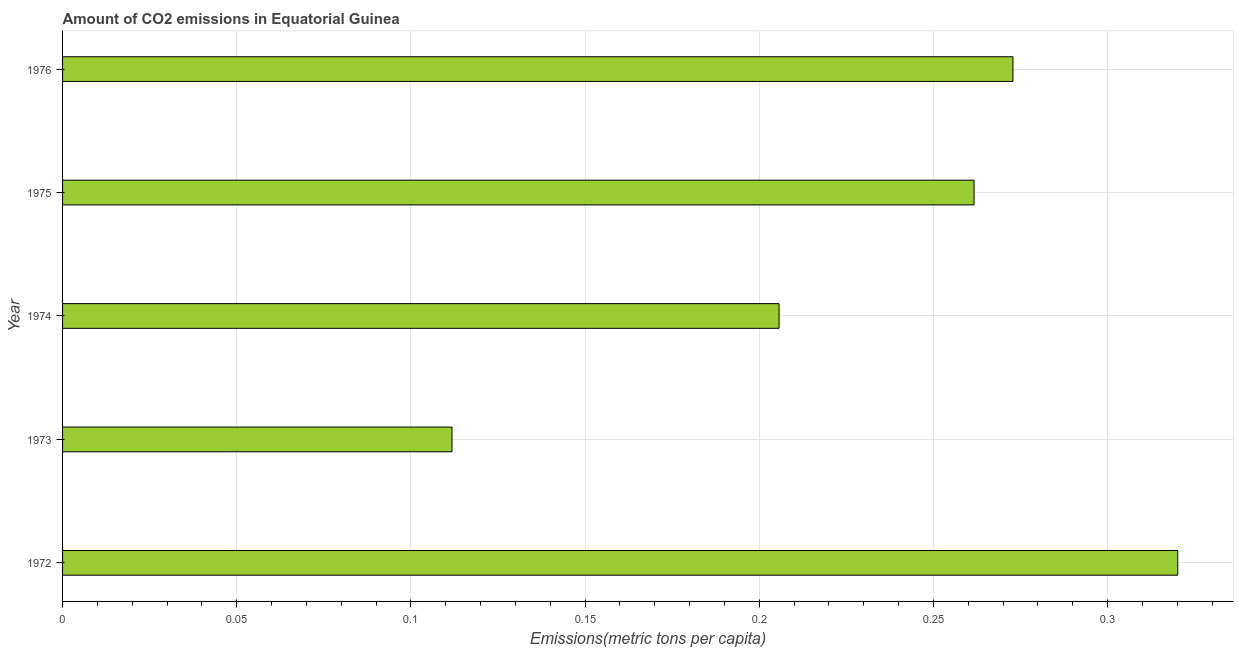What is the title of the graph?
Offer a very short reply. Amount of CO2 emissions in Equatorial Guinea. What is the label or title of the X-axis?
Your answer should be compact. Emissions(metric tons per capita). What is the amount of co2 emissions in 1975?
Keep it short and to the point. 0.26. Across all years, what is the maximum amount of co2 emissions?
Ensure brevity in your answer.  0.32. Across all years, what is the minimum amount of co2 emissions?
Offer a very short reply. 0.11. In which year was the amount of co2 emissions minimum?
Ensure brevity in your answer.  1973. What is the sum of the amount of co2 emissions?
Make the answer very short. 1.17. What is the difference between the amount of co2 emissions in 1973 and 1976?
Provide a succinct answer. -0.16. What is the average amount of co2 emissions per year?
Your response must be concise. 0.23. What is the median amount of co2 emissions?
Your answer should be very brief. 0.26. In how many years, is the amount of co2 emissions greater than 0.07 metric tons per capita?
Your response must be concise. 5. Do a majority of the years between 1976 and 1975 (inclusive) have amount of co2 emissions greater than 0.21 metric tons per capita?
Provide a succinct answer. No. What is the ratio of the amount of co2 emissions in 1972 to that in 1976?
Your answer should be compact. 1.17. What is the difference between the highest and the second highest amount of co2 emissions?
Keep it short and to the point. 0.05. Is the sum of the amount of co2 emissions in 1974 and 1975 greater than the maximum amount of co2 emissions across all years?
Your response must be concise. Yes. What is the difference between the highest and the lowest amount of co2 emissions?
Provide a succinct answer. 0.21. In how many years, is the amount of co2 emissions greater than the average amount of co2 emissions taken over all years?
Offer a very short reply. 3. Are the values on the major ticks of X-axis written in scientific E-notation?
Your answer should be compact. No. What is the Emissions(metric tons per capita) of 1972?
Ensure brevity in your answer.  0.32. What is the Emissions(metric tons per capita) in 1973?
Ensure brevity in your answer.  0.11. What is the Emissions(metric tons per capita) in 1974?
Your answer should be very brief. 0.21. What is the Emissions(metric tons per capita) of 1975?
Your answer should be compact. 0.26. What is the Emissions(metric tons per capita) in 1976?
Provide a succinct answer. 0.27. What is the difference between the Emissions(metric tons per capita) in 1972 and 1973?
Provide a short and direct response. 0.21. What is the difference between the Emissions(metric tons per capita) in 1972 and 1974?
Keep it short and to the point. 0.11. What is the difference between the Emissions(metric tons per capita) in 1972 and 1975?
Your answer should be compact. 0.06. What is the difference between the Emissions(metric tons per capita) in 1972 and 1976?
Your answer should be very brief. 0.05. What is the difference between the Emissions(metric tons per capita) in 1973 and 1974?
Offer a terse response. -0.09. What is the difference between the Emissions(metric tons per capita) in 1973 and 1975?
Your answer should be very brief. -0.15. What is the difference between the Emissions(metric tons per capita) in 1973 and 1976?
Keep it short and to the point. -0.16. What is the difference between the Emissions(metric tons per capita) in 1974 and 1975?
Offer a very short reply. -0.06. What is the difference between the Emissions(metric tons per capita) in 1974 and 1976?
Provide a succinct answer. -0.07. What is the difference between the Emissions(metric tons per capita) in 1975 and 1976?
Ensure brevity in your answer.  -0.01. What is the ratio of the Emissions(metric tons per capita) in 1972 to that in 1973?
Your answer should be compact. 2.86. What is the ratio of the Emissions(metric tons per capita) in 1972 to that in 1974?
Ensure brevity in your answer.  1.56. What is the ratio of the Emissions(metric tons per capita) in 1972 to that in 1975?
Offer a terse response. 1.22. What is the ratio of the Emissions(metric tons per capita) in 1972 to that in 1976?
Ensure brevity in your answer.  1.17. What is the ratio of the Emissions(metric tons per capita) in 1973 to that in 1974?
Make the answer very short. 0.54. What is the ratio of the Emissions(metric tons per capita) in 1973 to that in 1975?
Make the answer very short. 0.43. What is the ratio of the Emissions(metric tons per capita) in 1973 to that in 1976?
Your answer should be very brief. 0.41. What is the ratio of the Emissions(metric tons per capita) in 1974 to that in 1975?
Offer a very short reply. 0.79. What is the ratio of the Emissions(metric tons per capita) in 1974 to that in 1976?
Offer a terse response. 0.75. 